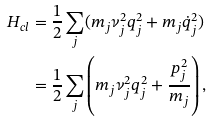<formula> <loc_0><loc_0><loc_500><loc_500>H _ { c l } & = \frac { 1 } { 2 } \sum _ { j } ( m _ { j } \nu _ { j } ^ { 2 } q _ { j } ^ { 2 } + m _ { j } \dot { q } _ { j } ^ { 2 } ) \\ & = \frac { 1 } { 2 } \sum _ { j } \left ( m _ { j } \nu _ { j } ^ { 2 } q _ { j } ^ { 2 } + \frac { p _ { j } ^ { 2 } } { m _ { j } } \right ) ,</formula> 